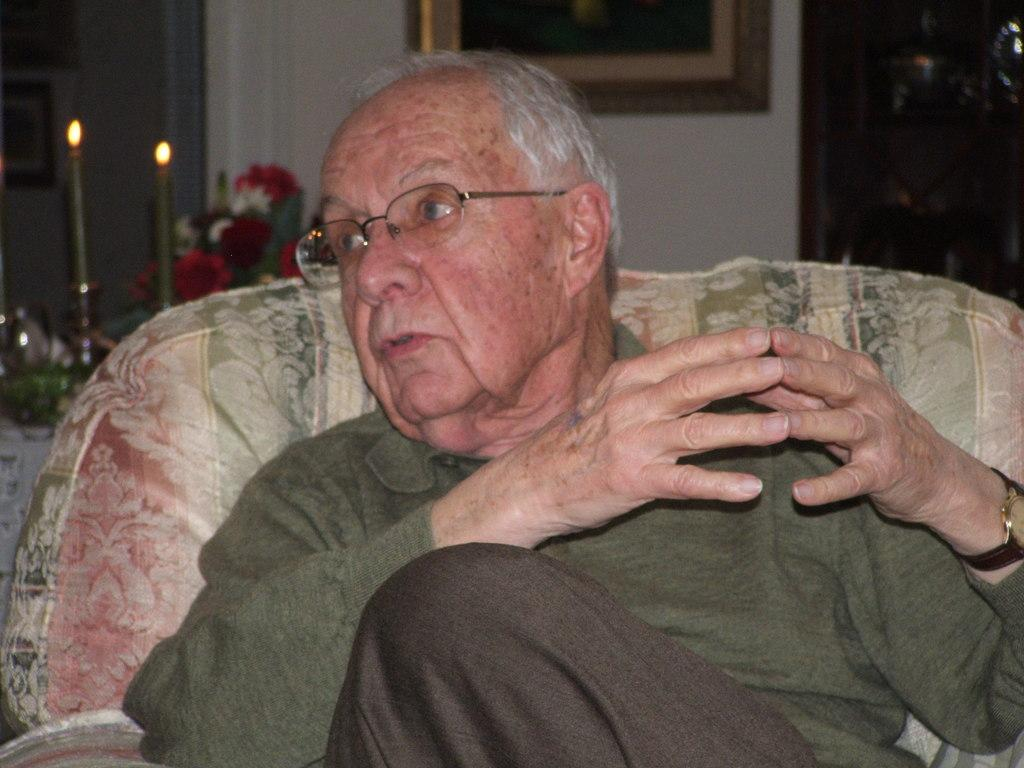What is the person in the image doing? The person is sitting on a chair in the image. What can be seen in the background of the image? There is a wall, a photo frame, candles, and flowers in the background of the image. What language is the person writing on the wall in the image? There is no writing on the wall in the image, so it is not possible to determine the language. 